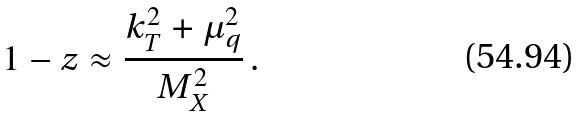Convert formula to latex. <formula><loc_0><loc_0><loc_500><loc_500>1 - z \approx \frac { k _ { T } ^ { 2 } + \mu _ { q } ^ { 2 } } { M _ { X } ^ { 2 } } \, .</formula> 